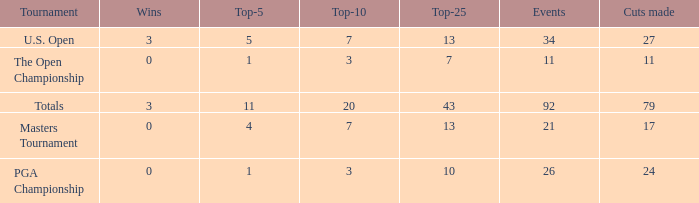Name the sum of top-25 for pga championship and top-5 less than 1 None. 